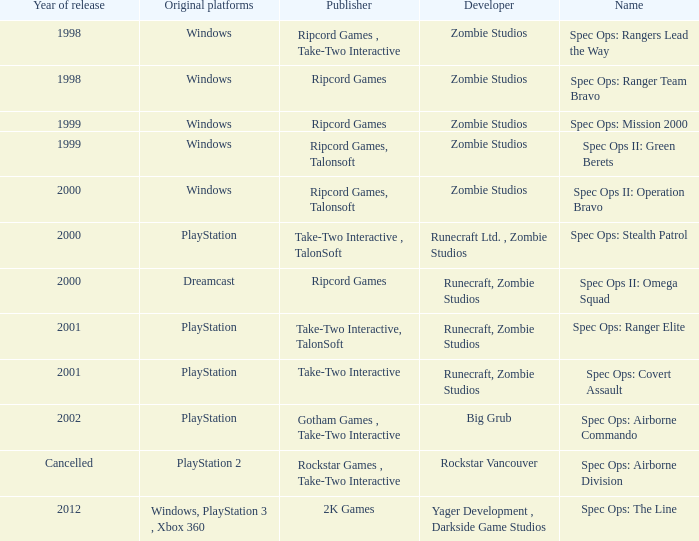Which publisher is responsible for spec ops: stealth patrol? Take-Two Interactive , TalonSoft. 